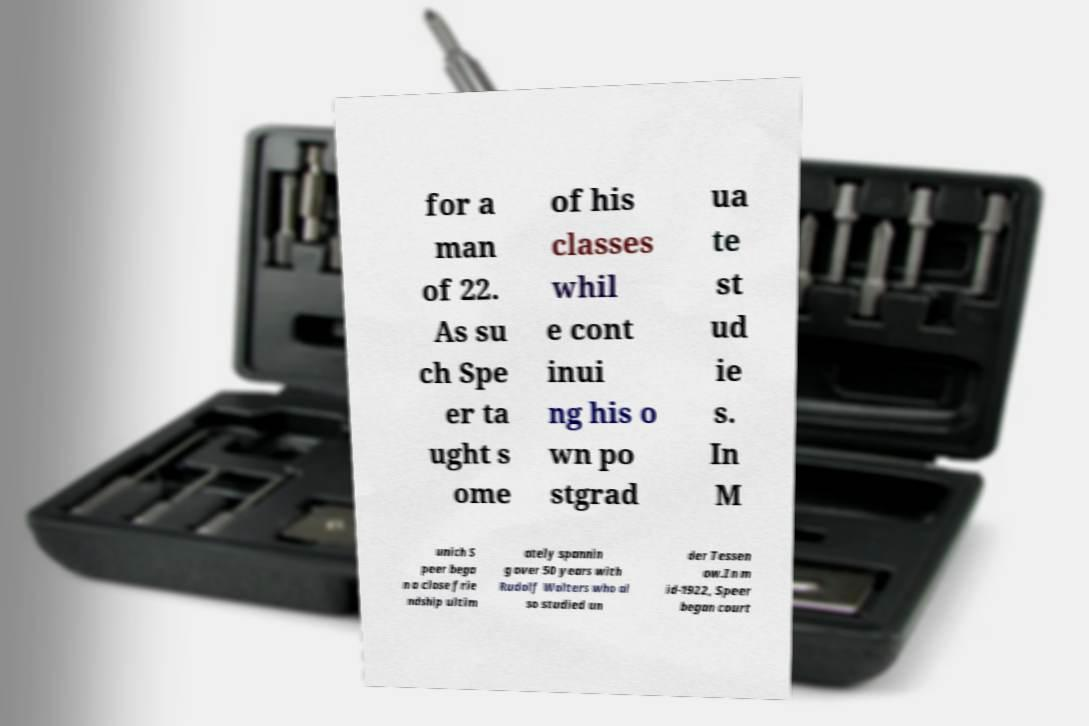Could you extract and type out the text from this image? for a man of 22. As su ch Spe er ta ught s ome of his classes whil e cont inui ng his o wn po stgrad ua te st ud ie s. In M unich S peer bega n a close frie ndship ultim ately spannin g over 50 years with Rudolf Wolters who al so studied un der Tessen ow.In m id-1922, Speer began court 